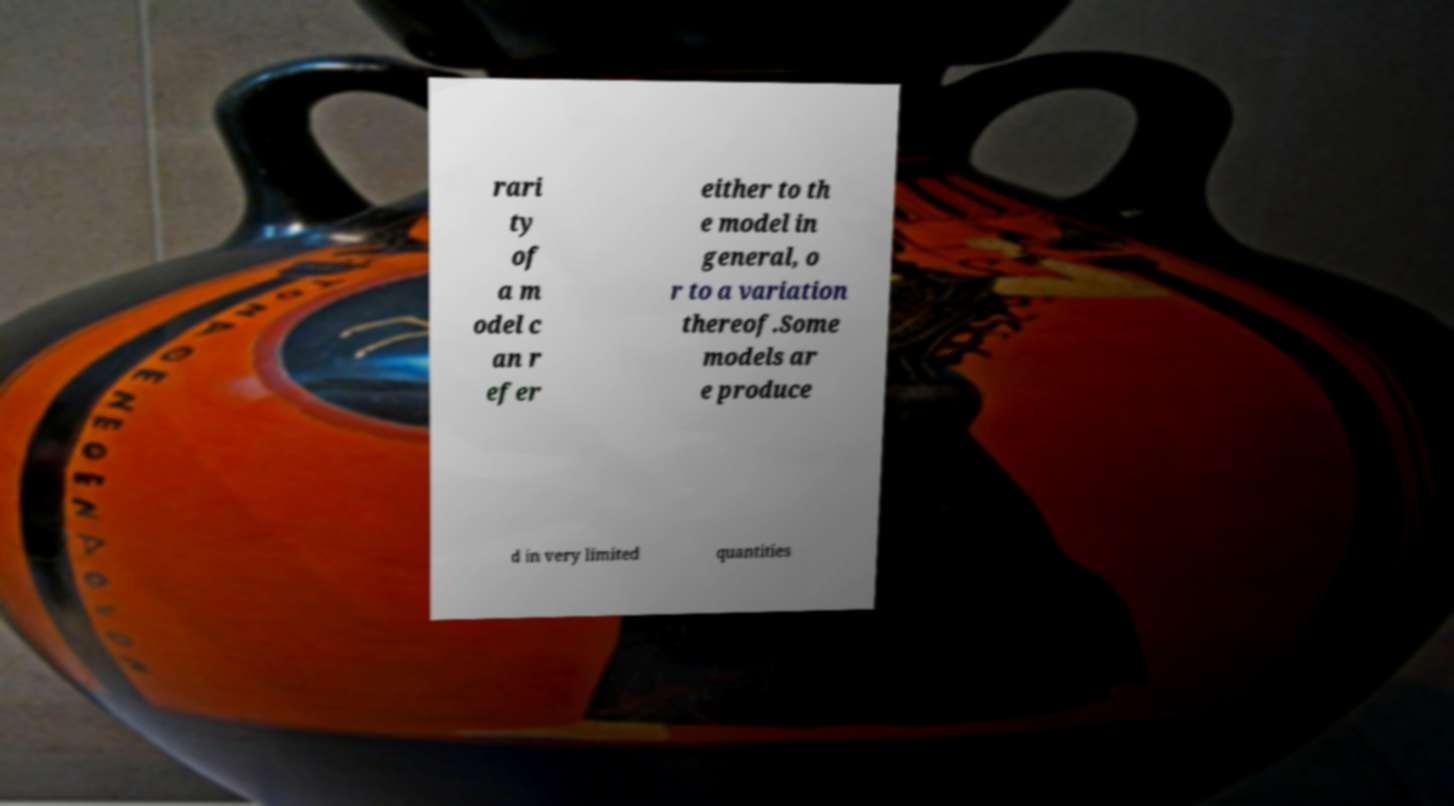There's text embedded in this image that I need extracted. Can you transcribe it verbatim? rari ty of a m odel c an r efer either to th e model in general, o r to a variation thereof.Some models ar e produce d in very limited quantities 